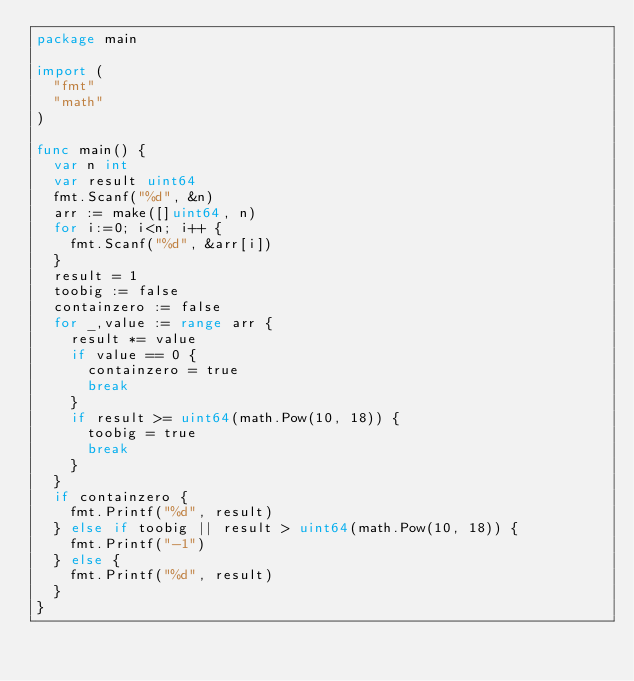<code> <loc_0><loc_0><loc_500><loc_500><_Go_>package main

import (
	"fmt"
	"math"
)

func main() {
	var n int
	var result uint64
	fmt.Scanf("%d", &n)
	arr := make([]uint64, n)
	for i:=0; i<n; i++ {
		fmt.Scanf("%d", &arr[i])
	}
	result = 1
	toobig := false
	containzero := false
	for _,value := range arr {
		result *= value
		if value == 0 {
			containzero = true
			break
		}
		if result >= uint64(math.Pow(10, 18)) {
			toobig = true
			break
		}
	}
	if containzero {
		fmt.Printf("%d", result)
	} else if toobig || result > uint64(math.Pow(10, 18)) {
		fmt.Printf("-1")
	} else {
		fmt.Printf("%d", result)
	}
}
</code> 